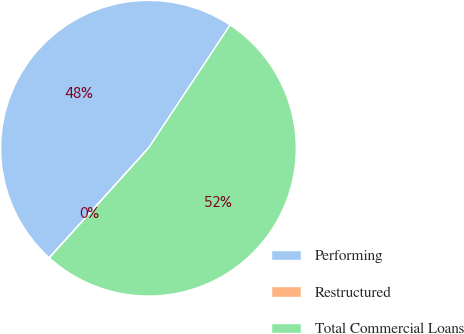Convert chart. <chart><loc_0><loc_0><loc_500><loc_500><pie_chart><fcel>Performing<fcel>Restructured<fcel>Total Commercial Loans<nl><fcel>47.6%<fcel>0.02%<fcel>52.38%<nl></chart> 